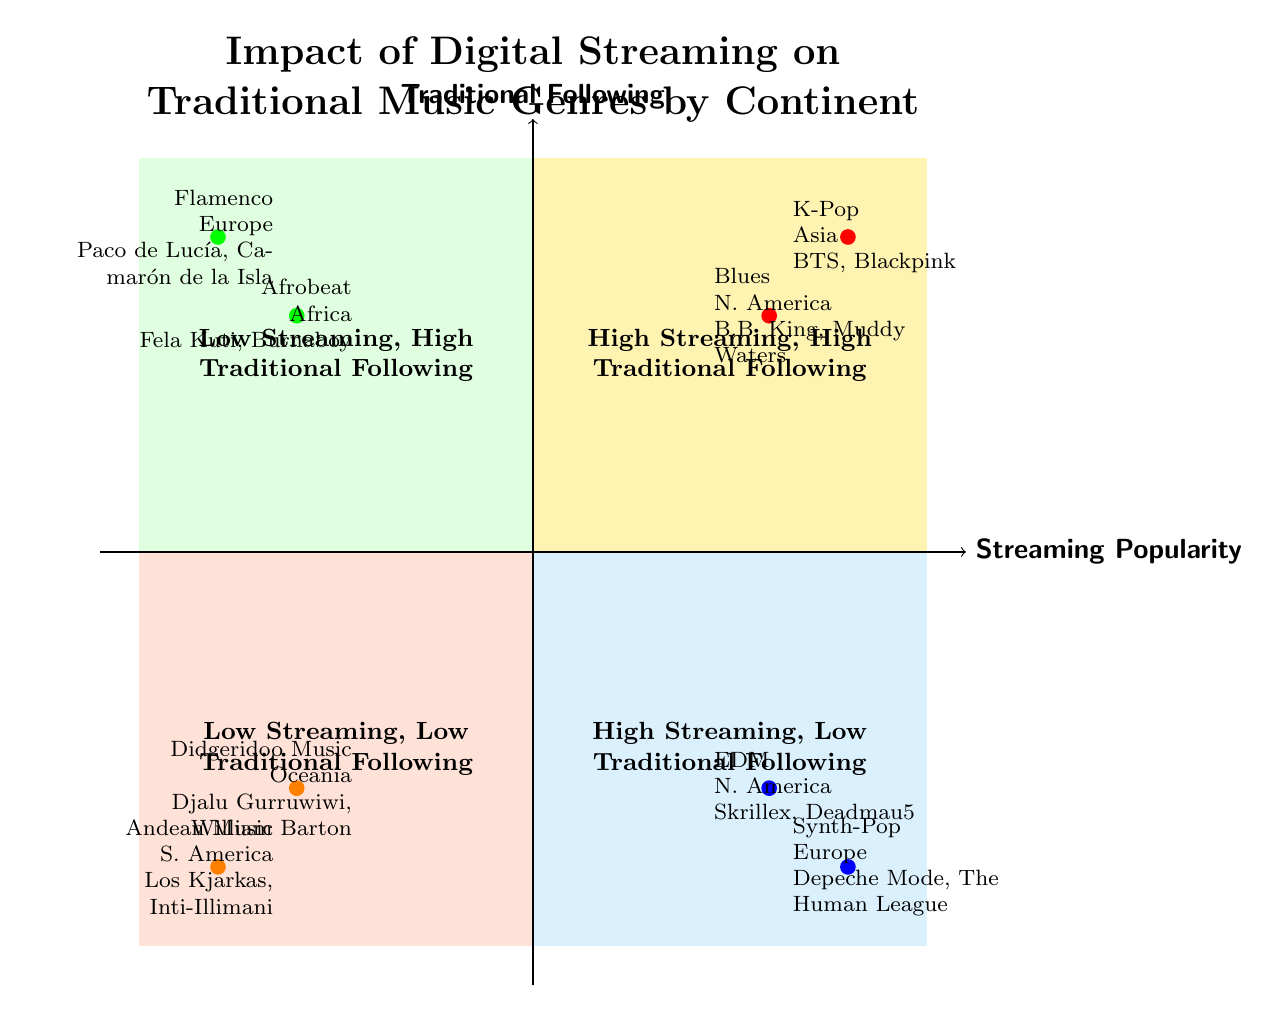What genre represents High Streaming, High Traditional Following in Africa? In the diagram's top right quadrant, representing High Streaming and High Traditional Following, Afrobeat is listed as the genre for Africa, along with its key artists.
Answer: Afrobeat Which continents are shown in the Low Streaming, High Traditional Following quadrant? The bottom left quadrant is labeled Low Streaming, High Traditional Following and includes examples from Africa and Europe, as evidenced by the genres and artists listed.
Answer: Africa, Europe How many genres are in the High Streaming, Low Traditional Following quadrant? The bottom right quadrant illustrates High Streaming, Low Traditional Following, containing two genres listed along with their respective continents and artists, thus totaling two genres.
Answer: 2 What genre associated with North America shows High Streaming but Low Traditional Following? In the bottom right quadrant, which indicates High Streaming and Low Traditional Following, EDM is specifically noted as the genre for North America, along with prominent artists.
Answer: EDM Which genre has the highest traditional following among the examples listed? Evaluating the top left quadrant, which features Low Streaming but High Traditional Following, Flamenco is represented as having a strong traditional following as defined by its enduring popularity and key artists.
Answer: Flamenco What key artists are associated with K-Pop in the diagram? The K-Pop genre, indicated in the top right quadrant, showcases its popularity with high streaming and traditional following, listing BTS and Blackpink as notable key artists.
Answer: BTS, Blackpink Which continent features Didgeridoo Music? In the bottom left quadrant, classified as Low Streaming and Low Traditional Following, Didgeridoo Music is associated with Oceania, as seen in the genres and artists highlighted.
Answer: Oceania What is the position of Synth-Pop in the diagram? Synth-Pop is situated in the bottom right quadrant, indicating High Streaming but Low Traditional Following; this is confirmed by its specified location and associated key artists in the chart.
Answer: Bottom Right Quadrant 